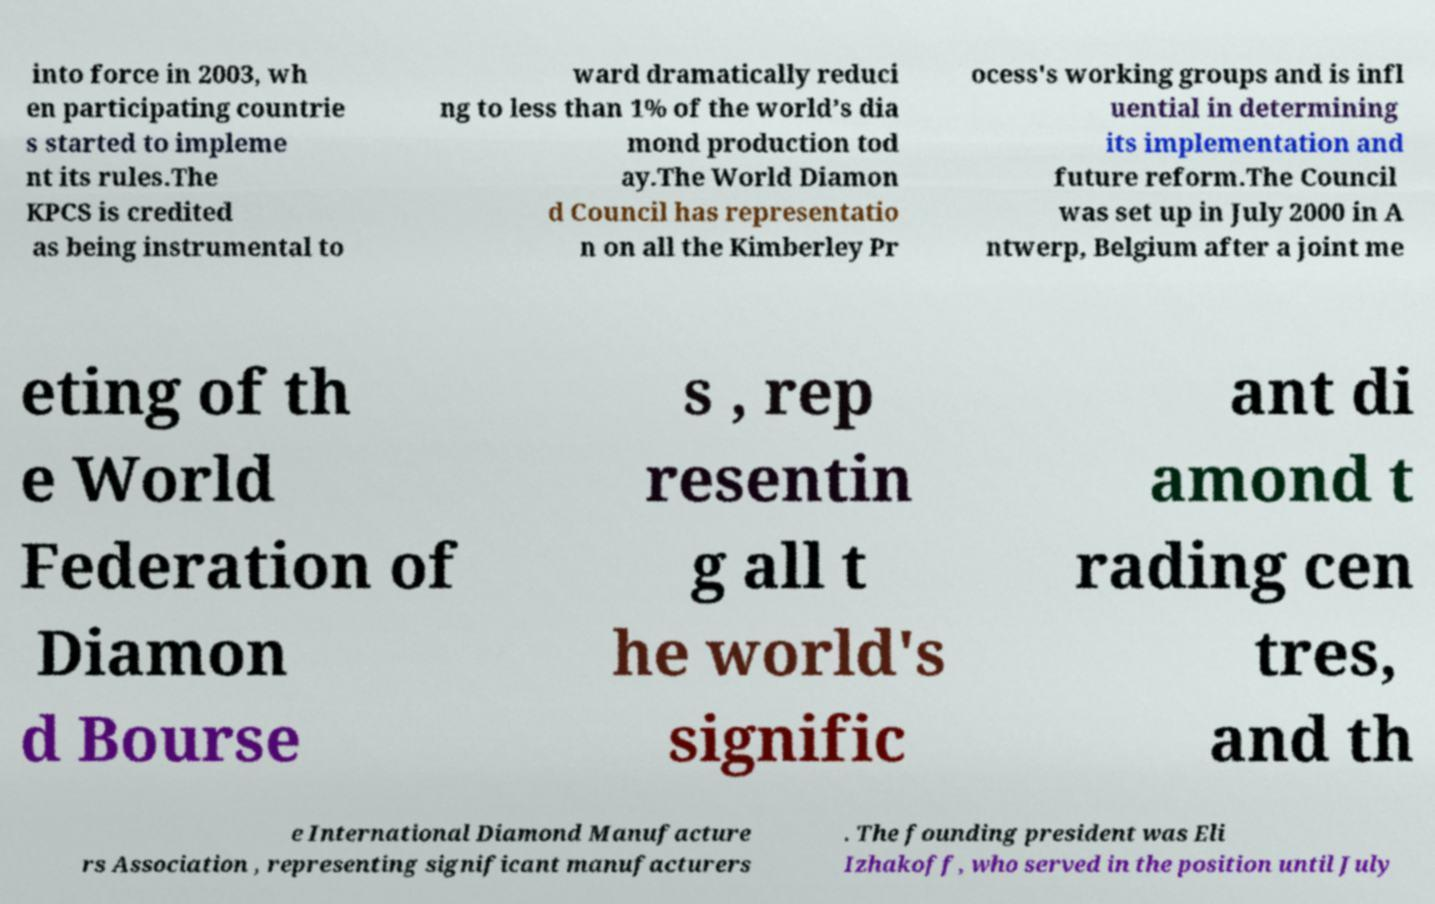I need the written content from this picture converted into text. Can you do that? into force in 2003, wh en participating countrie s started to impleme nt its rules.The KPCS is credited as being instrumental to ward dramatically reduci ng to less than 1% of the world’s dia mond production tod ay.The World Diamon d Council has representatio n on all the Kimberley Pr ocess's working groups and is infl uential in determining its implementation and future reform.The Council was set up in July 2000 in A ntwerp, Belgium after a joint me eting of th e World Federation of Diamon d Bourse s , rep resentin g all t he world's signific ant di amond t rading cen tres, and th e International Diamond Manufacture rs Association , representing significant manufacturers . The founding president was Eli Izhakoff, who served in the position until July 